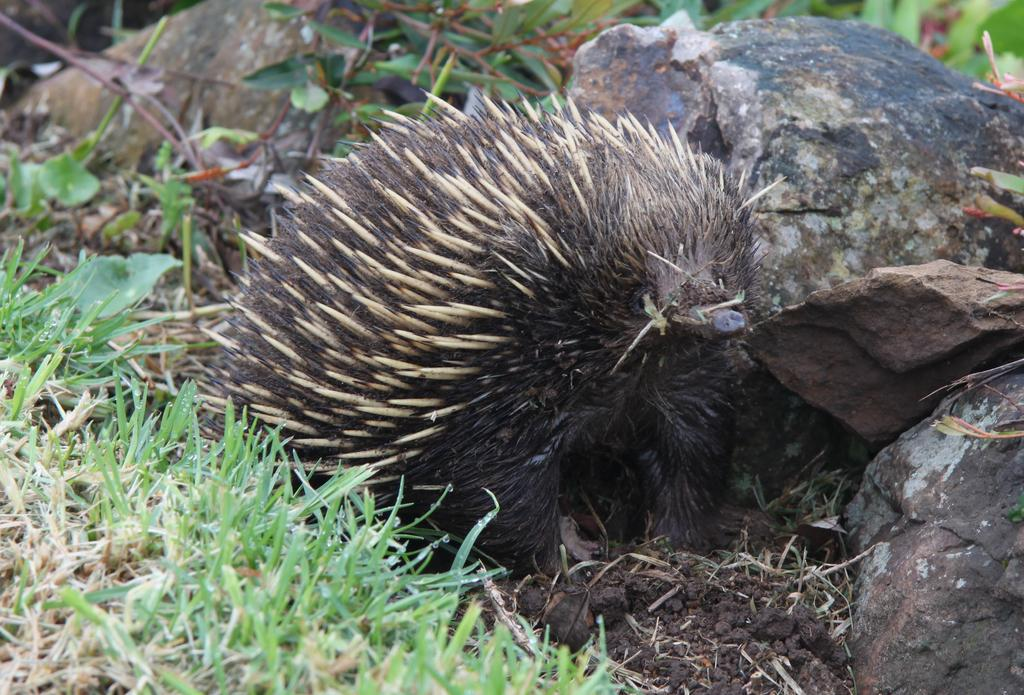What animal is in the image? There is an echidna in the image. Where is the echidna located? The echidna is on the ground. What type of vegetation is on the left side of the image? There is grass on the left side of the image. What type of material is on the right side of the image? There are stones on the right side of the image. What type of sound can be heard coming from the echidna in the image? There is no indication of any sound coming from the echidna in the image. What meal is the echidna eating in the image? There is no meal present in the image; the echidna is simply on the ground. 